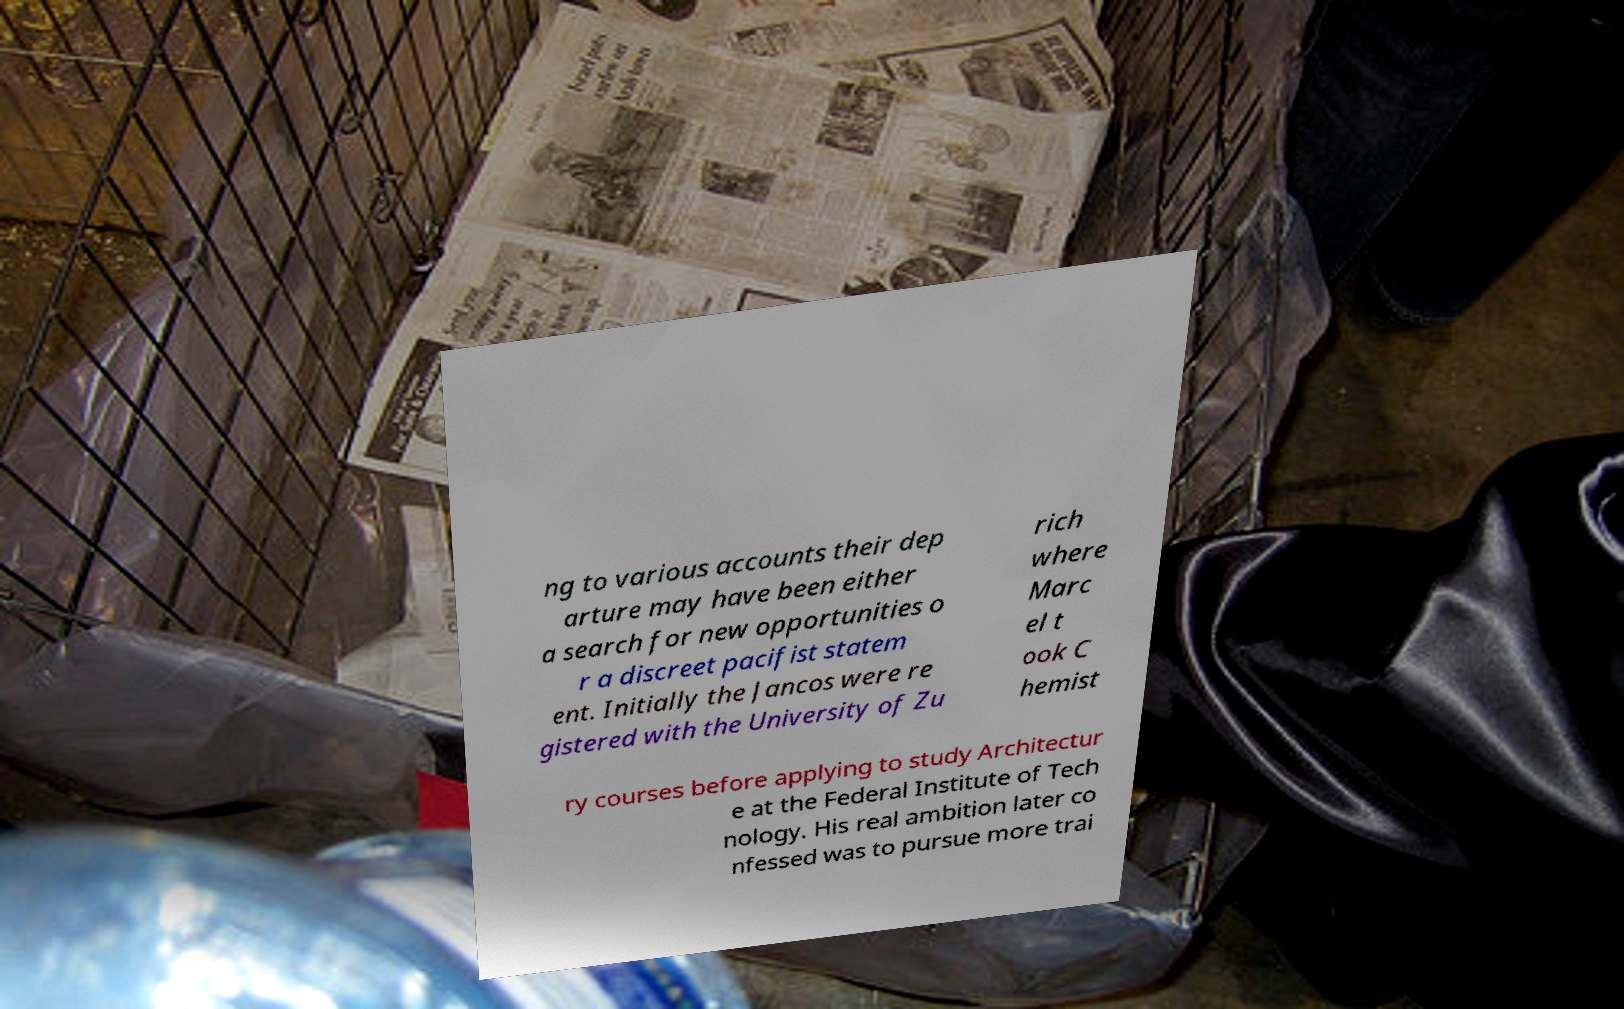Please identify and transcribe the text found in this image. ng to various accounts their dep arture may have been either a search for new opportunities o r a discreet pacifist statem ent. Initially the Jancos were re gistered with the University of Zu rich where Marc el t ook C hemist ry courses before applying to study Architectur e at the Federal Institute of Tech nology. His real ambition later co nfessed was to pursue more trai 